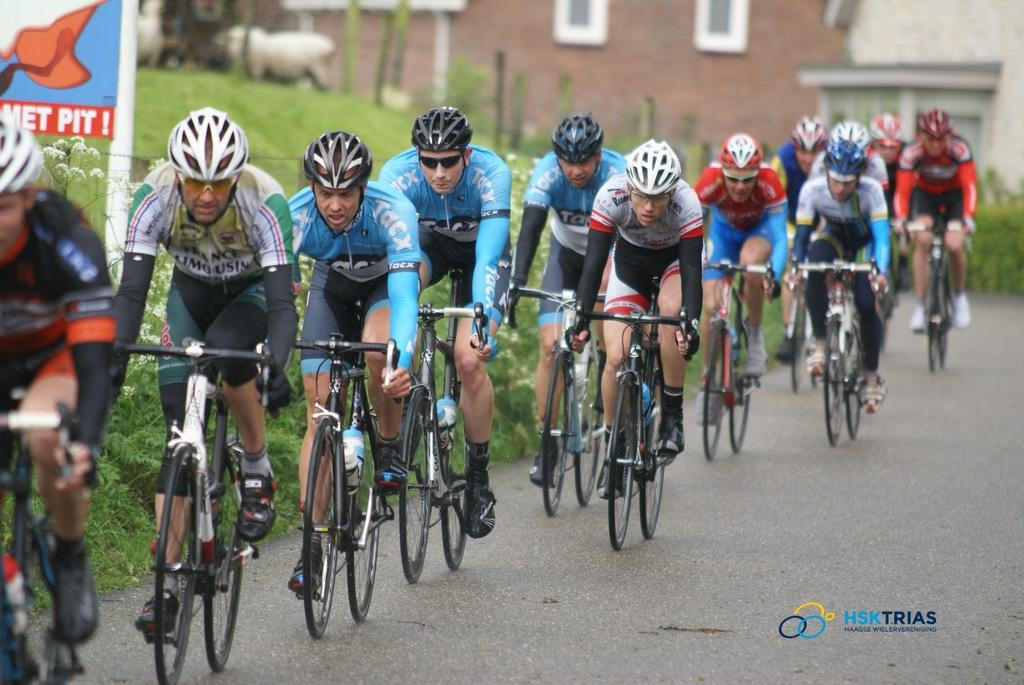What are the people in the image doing? The people in the image are riding cycles. Where are the cycles located? The cycles are on a road. What can be seen on the left side of the image? There is grass on the left side of the image. What structure is in the middle of the image? There is a house in the middle of the image. What type of cover is protecting the people from flight in the image? There is no cover or flight present in the image; the people are riding cycles on a road. 